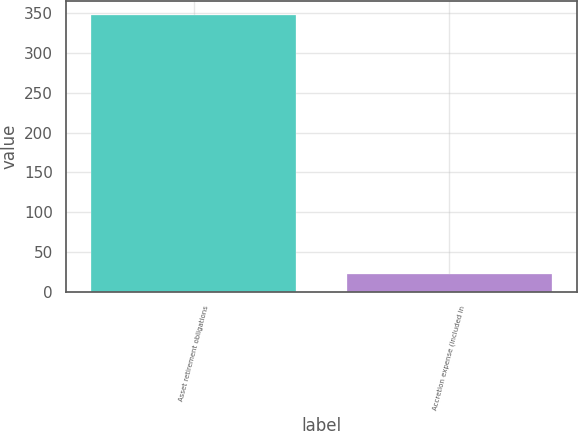Convert chart. <chart><loc_0><loc_0><loc_500><loc_500><bar_chart><fcel>Asset retirement obligations<fcel>Accretion expense (included in<nl><fcel>347.6<fcel>23<nl></chart> 